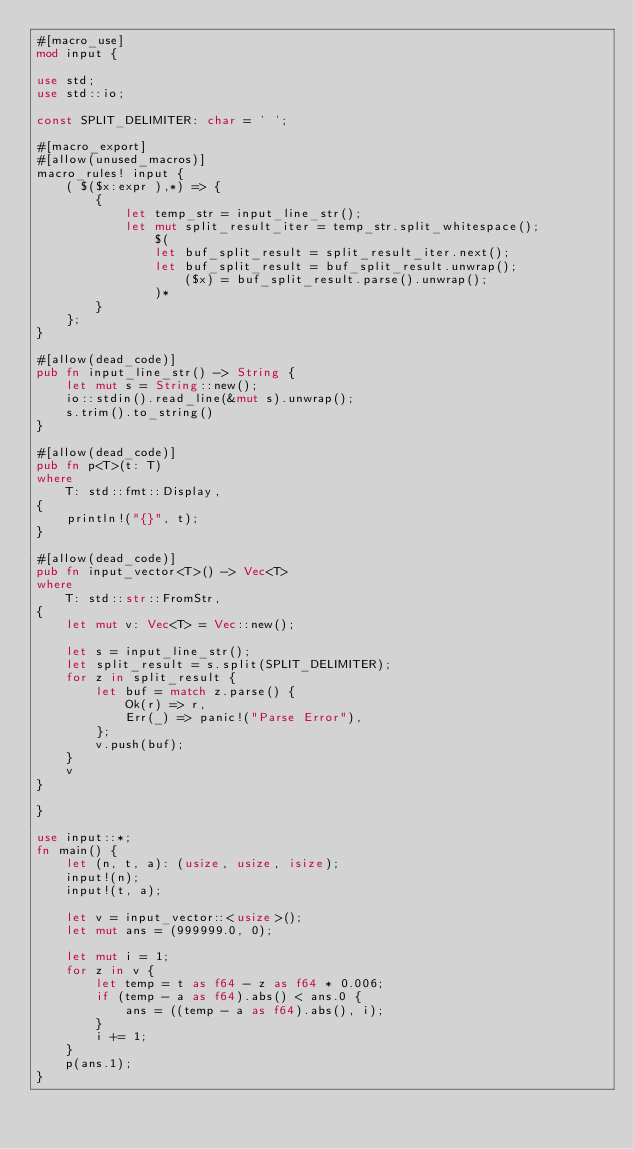<code> <loc_0><loc_0><loc_500><loc_500><_Rust_>#[macro_use]
mod input {

use std;
use std::io;

const SPLIT_DELIMITER: char = ' ';

#[macro_export]
#[allow(unused_macros)]
macro_rules! input {
    ( $($x:expr ),*) => {
        {
            let temp_str = input_line_str();
            let mut split_result_iter = temp_str.split_whitespace();
                $(
                let buf_split_result = split_result_iter.next();
                let buf_split_result = buf_split_result.unwrap();
                    ($x) = buf_split_result.parse().unwrap();
                )*
        }
    };
}

#[allow(dead_code)]
pub fn input_line_str() -> String {
    let mut s = String::new();
    io::stdin().read_line(&mut s).unwrap();
    s.trim().to_string()
}

#[allow(dead_code)]
pub fn p<T>(t: T)
where
    T: std::fmt::Display,
{
    println!("{}", t);
}

#[allow(dead_code)]
pub fn input_vector<T>() -> Vec<T>
where
    T: std::str::FromStr,
{
    let mut v: Vec<T> = Vec::new();

    let s = input_line_str();
    let split_result = s.split(SPLIT_DELIMITER);
    for z in split_result {
        let buf = match z.parse() {
            Ok(r) => r,
            Err(_) => panic!("Parse Error"),
        };
        v.push(buf);
    }
    v
}

}

use input::*;
fn main() {
    let (n, t, a): (usize, usize, isize);
    input!(n);
    input!(t, a);

    let v = input_vector::<usize>();
    let mut ans = (999999.0, 0);

    let mut i = 1;
    for z in v {
        let temp = t as f64 - z as f64 * 0.006;
        if (temp - a as f64).abs() < ans.0 {
            ans = ((temp - a as f64).abs(), i);
        }
        i += 1;
    }
    p(ans.1);
}
</code> 